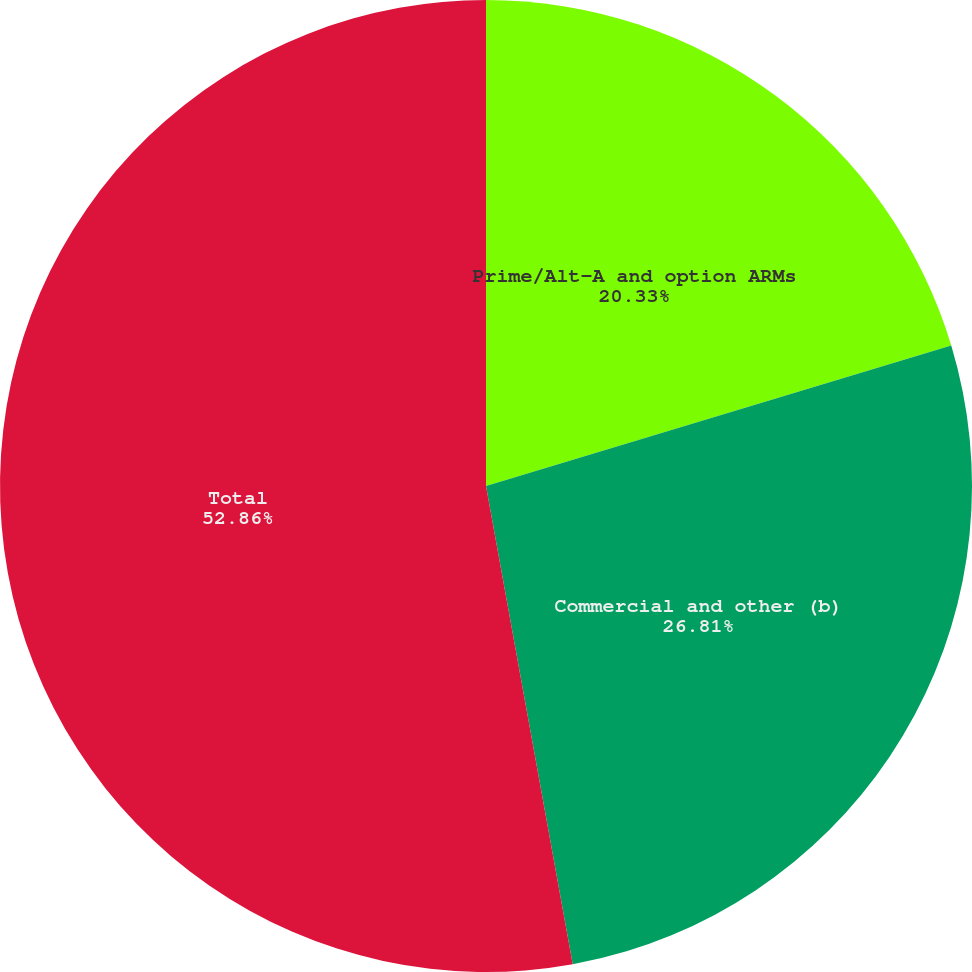Convert chart. <chart><loc_0><loc_0><loc_500><loc_500><pie_chart><fcel>Prime/Alt-A and option ARMs<fcel>Commercial and other (b)<fcel>Total<nl><fcel>20.33%<fcel>26.81%<fcel>52.85%<nl></chart> 